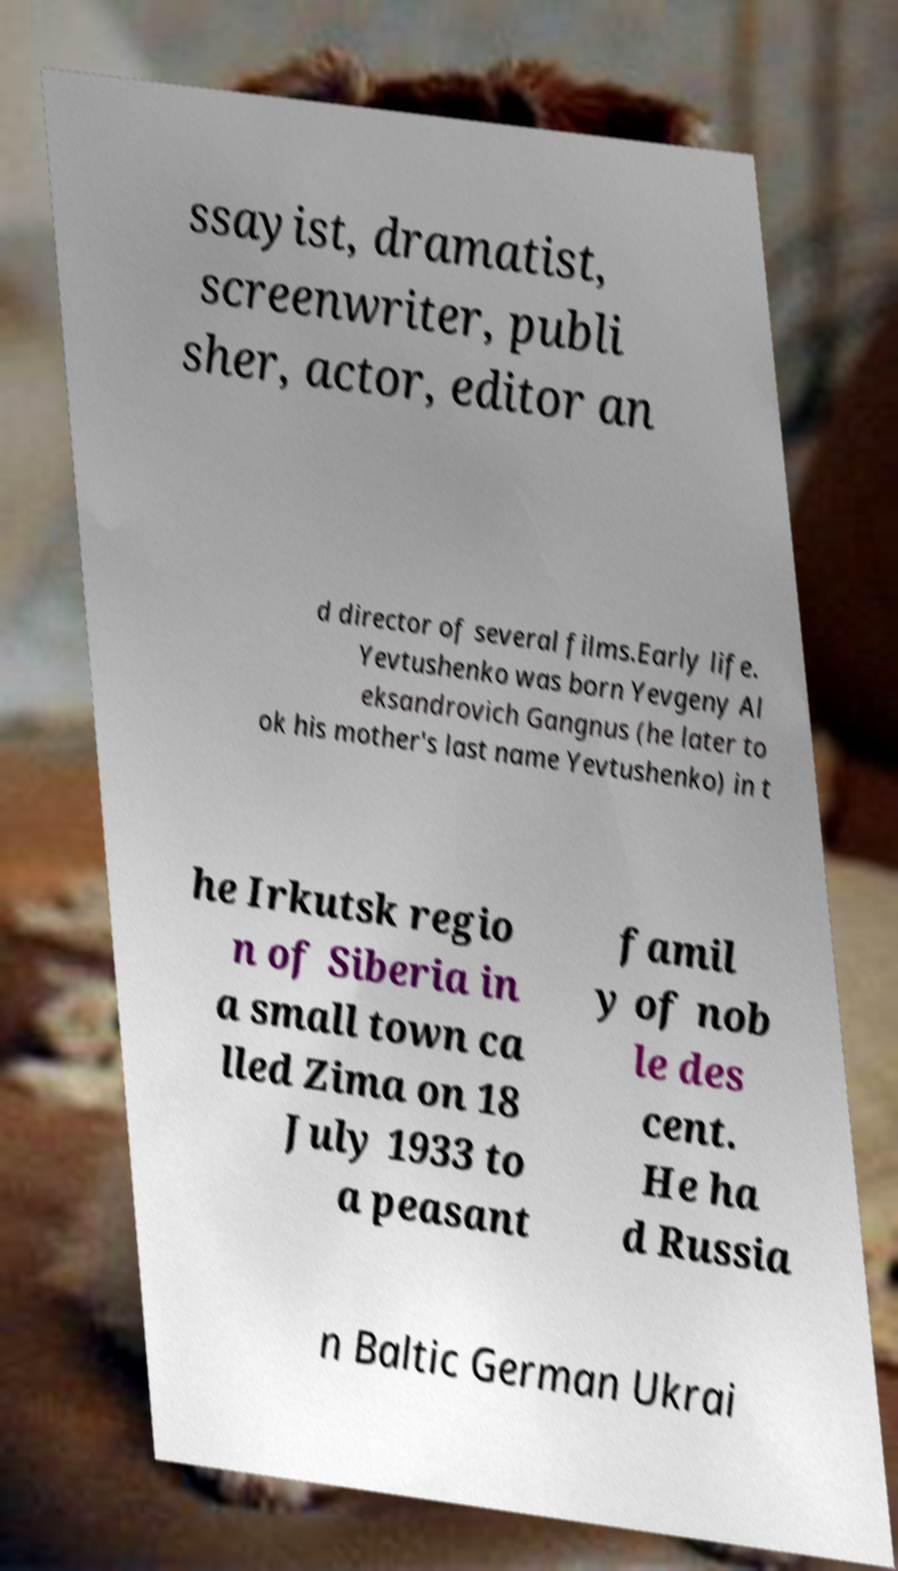Please identify and transcribe the text found in this image. ssayist, dramatist, screenwriter, publi sher, actor, editor an d director of several films.Early life. Yevtushenko was born Yevgeny Al eksandrovich Gangnus (he later to ok his mother's last name Yevtushenko) in t he Irkutsk regio n of Siberia in a small town ca lled Zima on 18 July 1933 to a peasant famil y of nob le des cent. He ha d Russia n Baltic German Ukrai 